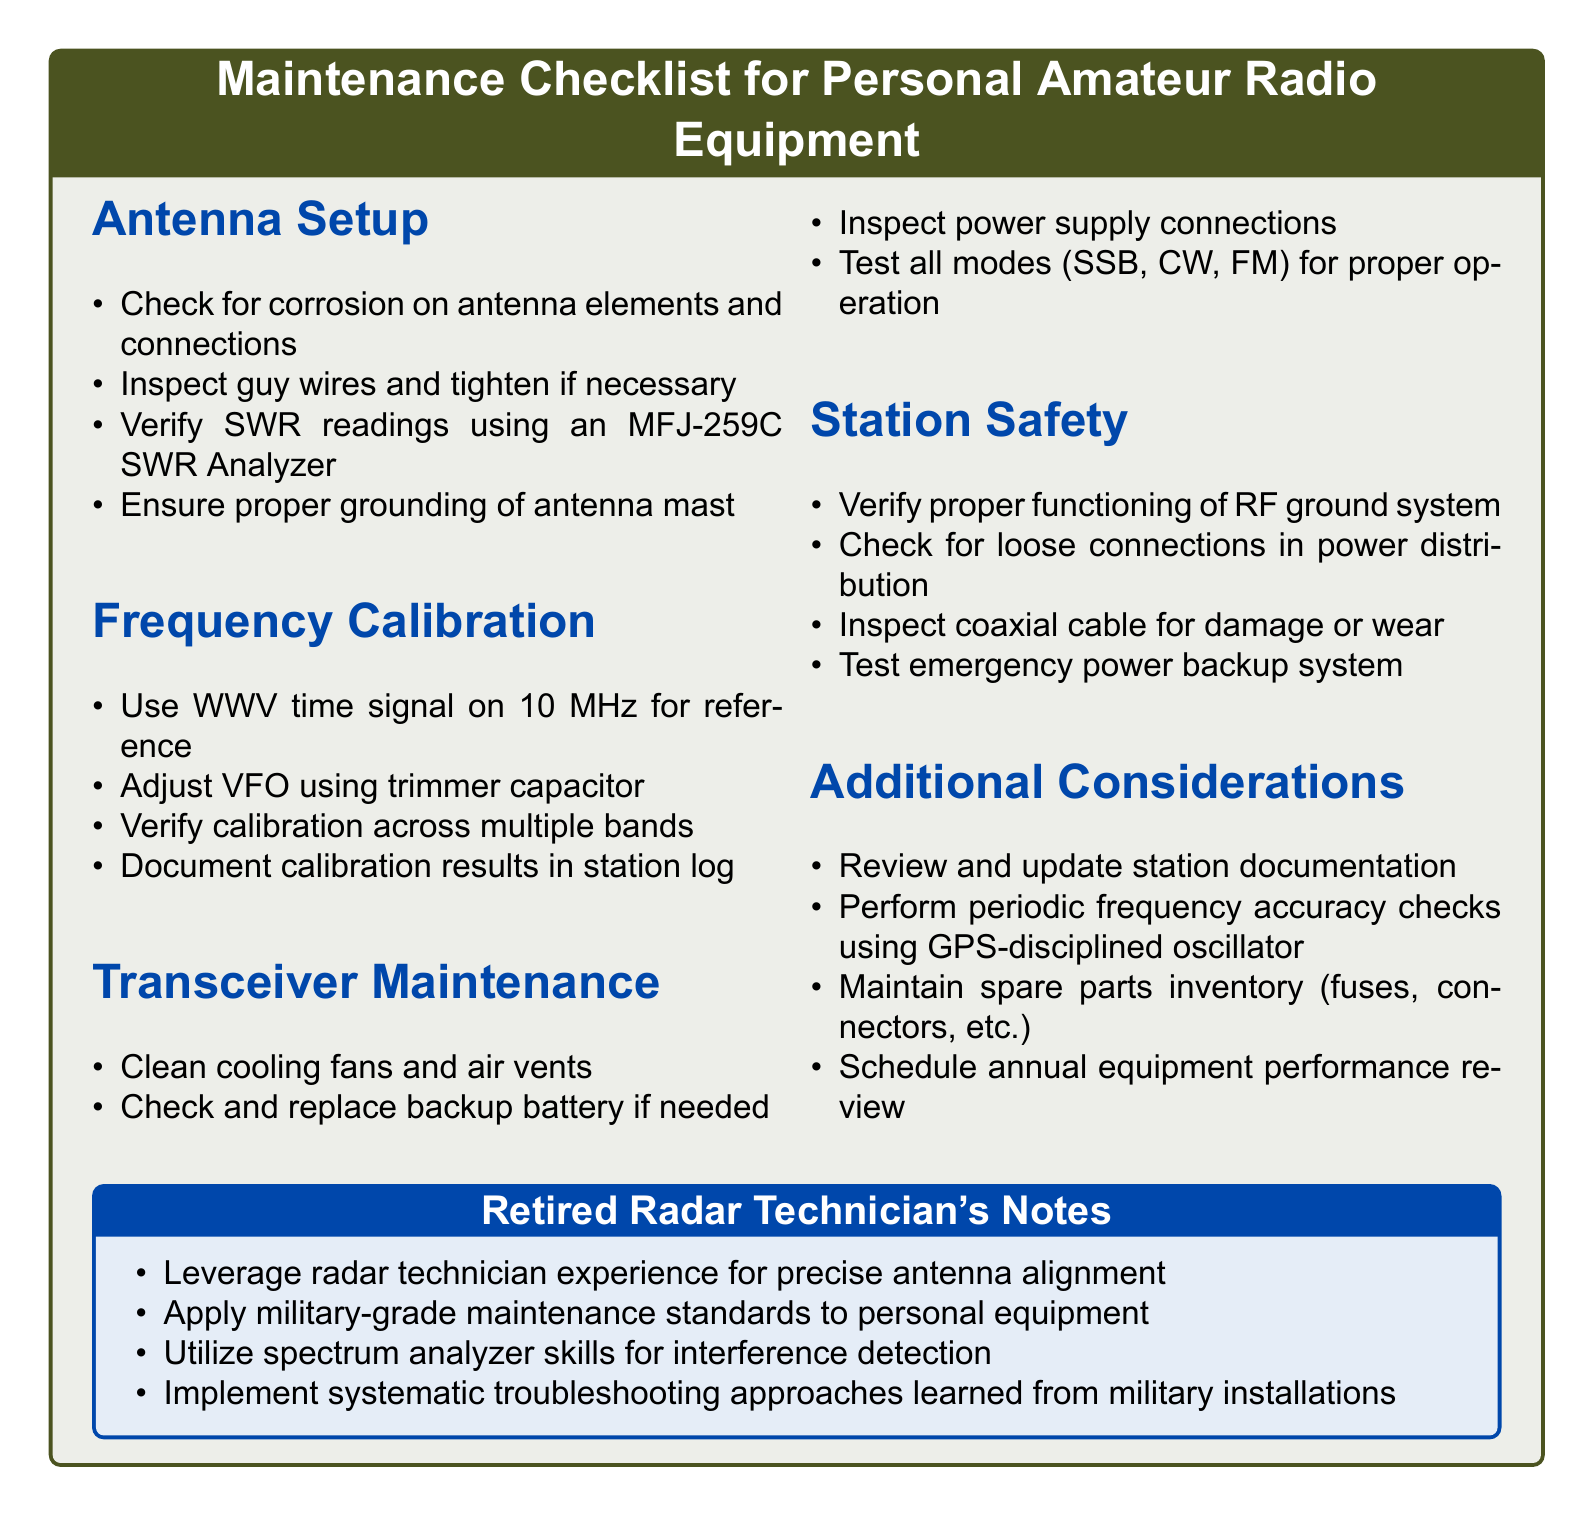What is the first item in the Antenna Setup section? The first item is listed under Antenna Setup in the document.
Answer: Check for corrosion on antenna elements and connections How many items are listed under Frequency Calibration? The number of items can be found in the Frequency Calibration section of the document.
Answer: Four What equipment is used to verify SWR readings? This question refers to the specific equipment mentioned in the Antenna Setup section.
Answer: MFJ-259C SWR Analyzer Which signal should be used for frequency calibration? The reference signal for frequency calibration is specified in the Frequency Calibration section.
Answer: WWV time signal on 10 MHz What the last item is listed in the Additional Considerations section? The last item can be found at the bottom of the Additional Considerations section in the document.
Answer: Schedule annual equipment performance review What should be documented after frequency calibration? The document specifies what needs to be recorded after performing frequency calibration.
Answer: Calibration results in station log What safety measure is advised for coaxial cable? The document gives advice on inspecting coaxial cable under the Station Safety section.
Answer: Inspect coaxial cable for damage or wear 